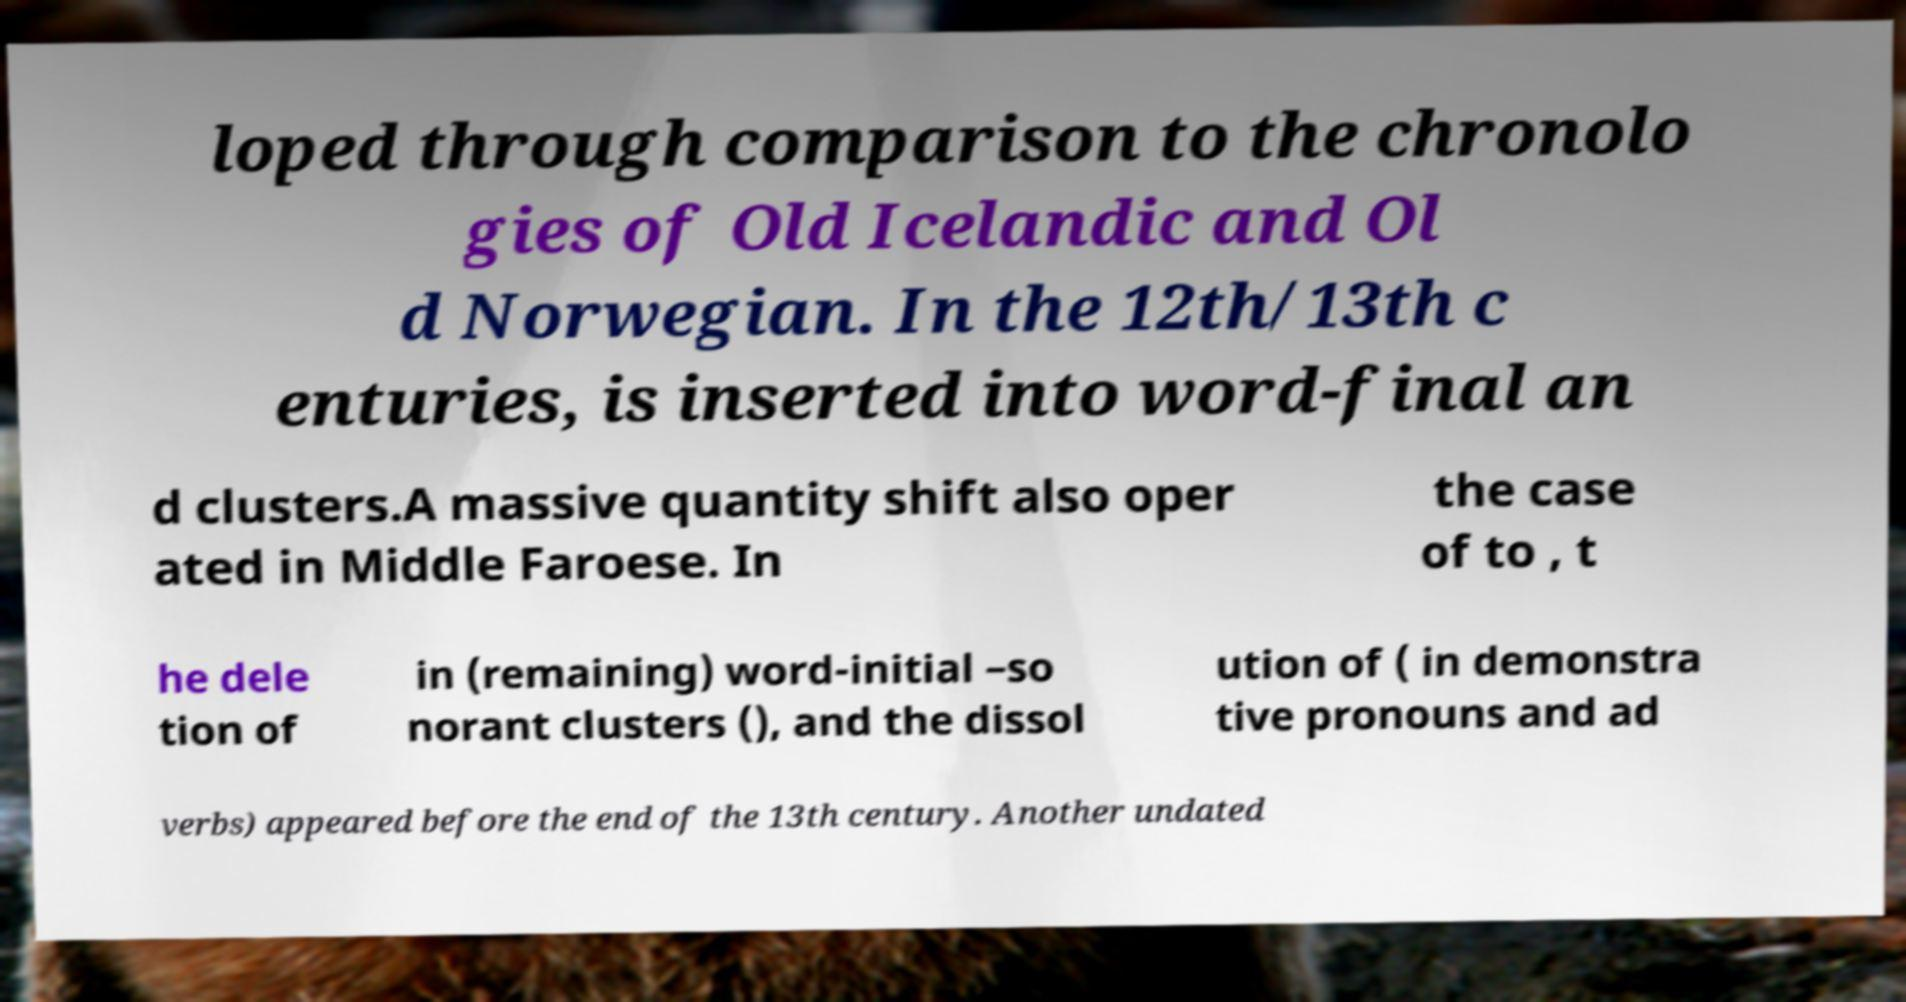Could you assist in decoding the text presented in this image and type it out clearly? loped through comparison to the chronolo gies of Old Icelandic and Ol d Norwegian. In the 12th/13th c enturies, is inserted into word-final an d clusters.A massive quantity shift also oper ated in Middle Faroese. In the case of to , t he dele tion of in (remaining) word-initial –so norant clusters (), and the dissol ution of ( in demonstra tive pronouns and ad verbs) appeared before the end of the 13th century. Another undated 